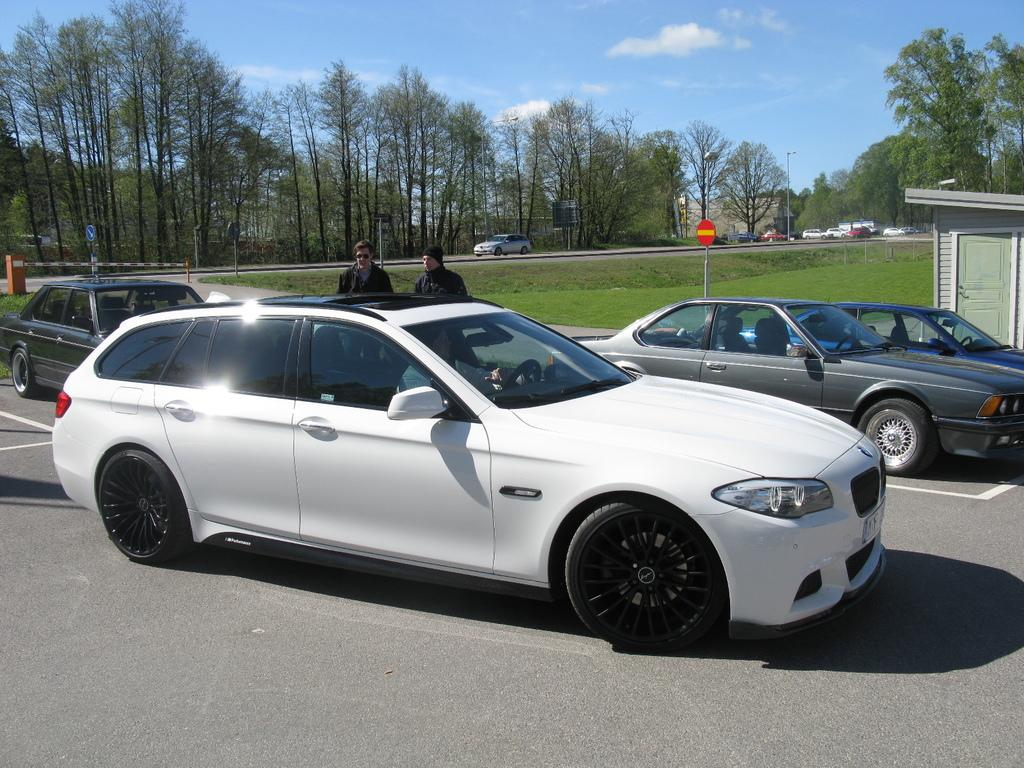What can be seen on the road in the image? There are vehicles on the road in the image. What is visible in the background of the image? There are trees, boards, poles, and people in the background of the image. What type of structures can be seen in the image? There are sheds in the image. What is visible at the top of the image? The sky is visible at the top of the image, and there are clouds in the sky. Can you tell me how many times the people in the image run to the ocean? There is no ocean present in the image, and therefore no running to the ocean can be observed. What happens when the vehicles in the image try to crush the poles? There is no indication in the image that the vehicles are trying to crush the poles, so it cannot be determined from the picture. 